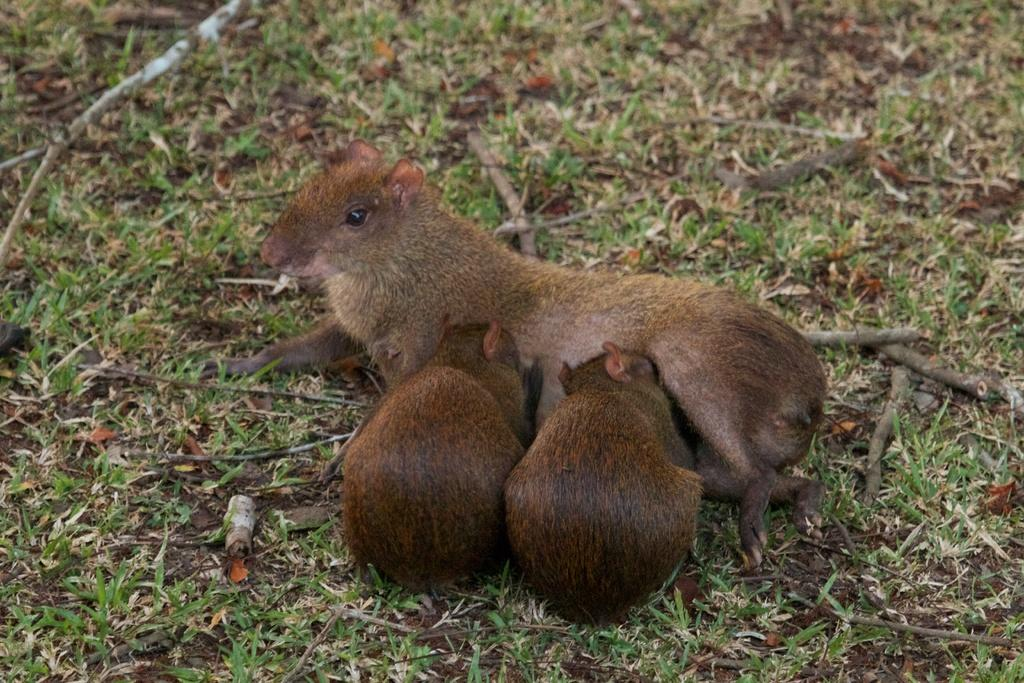How many rats are present in the image? There are three rats in the image. Where are the rats located? The rats are on the surface of the grass. What type of nest can be seen in the image? There is no nest present in the image; it features three rats on the grass. Who is the visitor in the image? There is no visitor present in the image; it only shows three rats on the grass. 